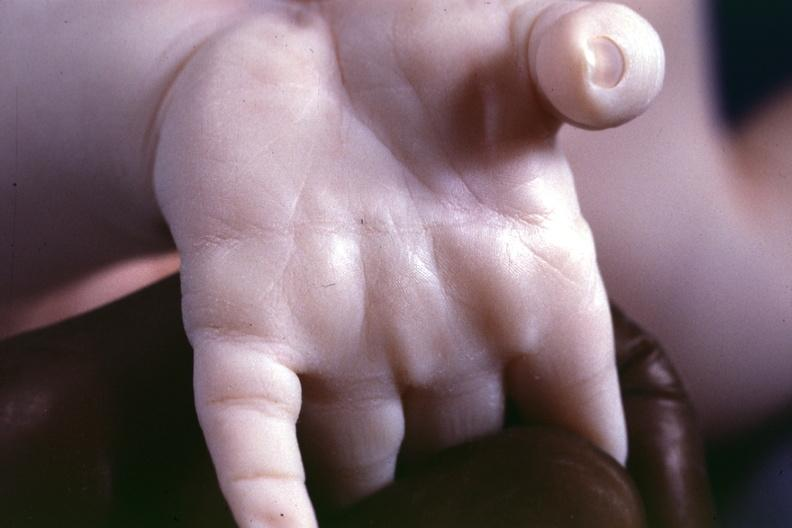re extremities present?
Answer the question using a single word or phrase. Yes 